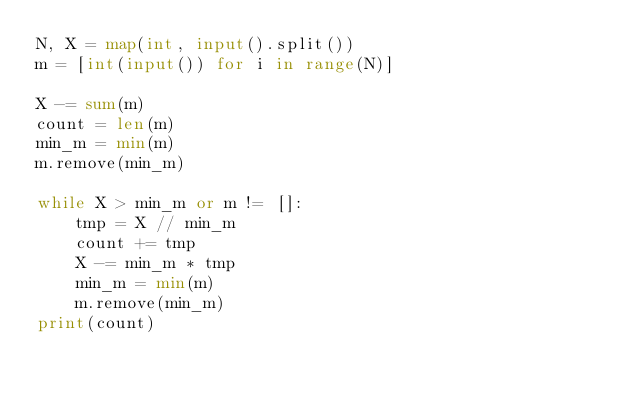Convert code to text. <code><loc_0><loc_0><loc_500><loc_500><_Python_>N, X = map(int, input().split())
m = [int(input()) for i in range(N)]

X -= sum(m)
count = len(m)
min_m = min(m)
m.remove(min_m)

while X > min_m or m != []:
    tmp = X // min_m
    count += tmp
    X -= min_m * tmp
    min_m = min(m)
    m.remove(min_m)
print(count)</code> 